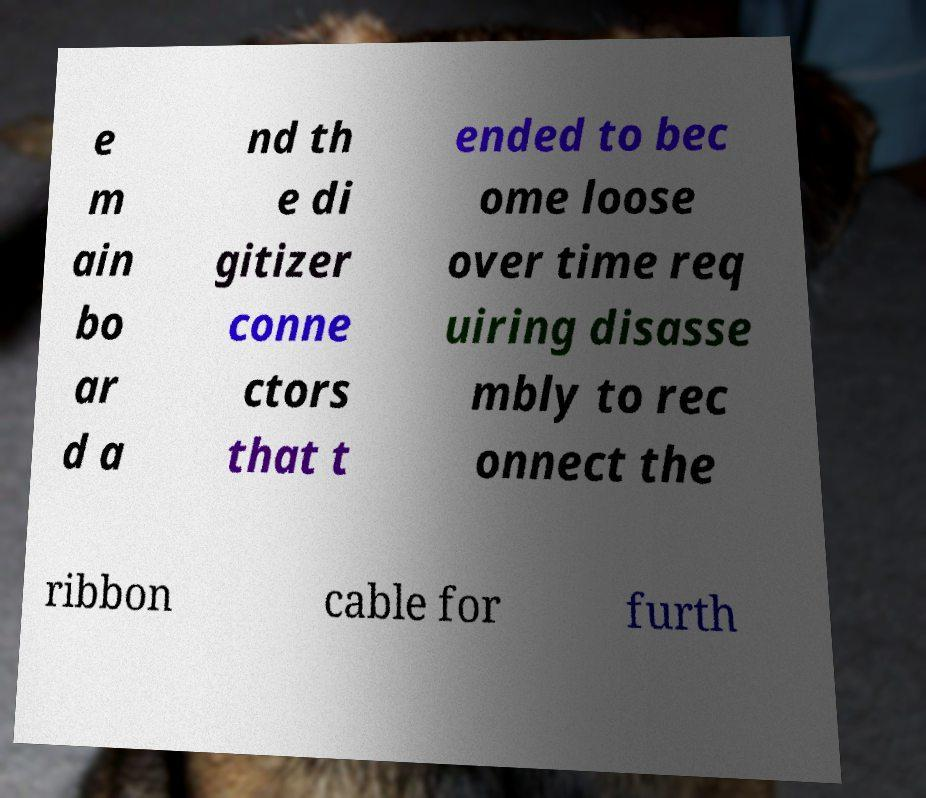Could you assist in decoding the text presented in this image and type it out clearly? e m ain bo ar d a nd th e di gitizer conne ctors that t ended to bec ome loose over time req uiring disasse mbly to rec onnect the ribbon cable for furth 